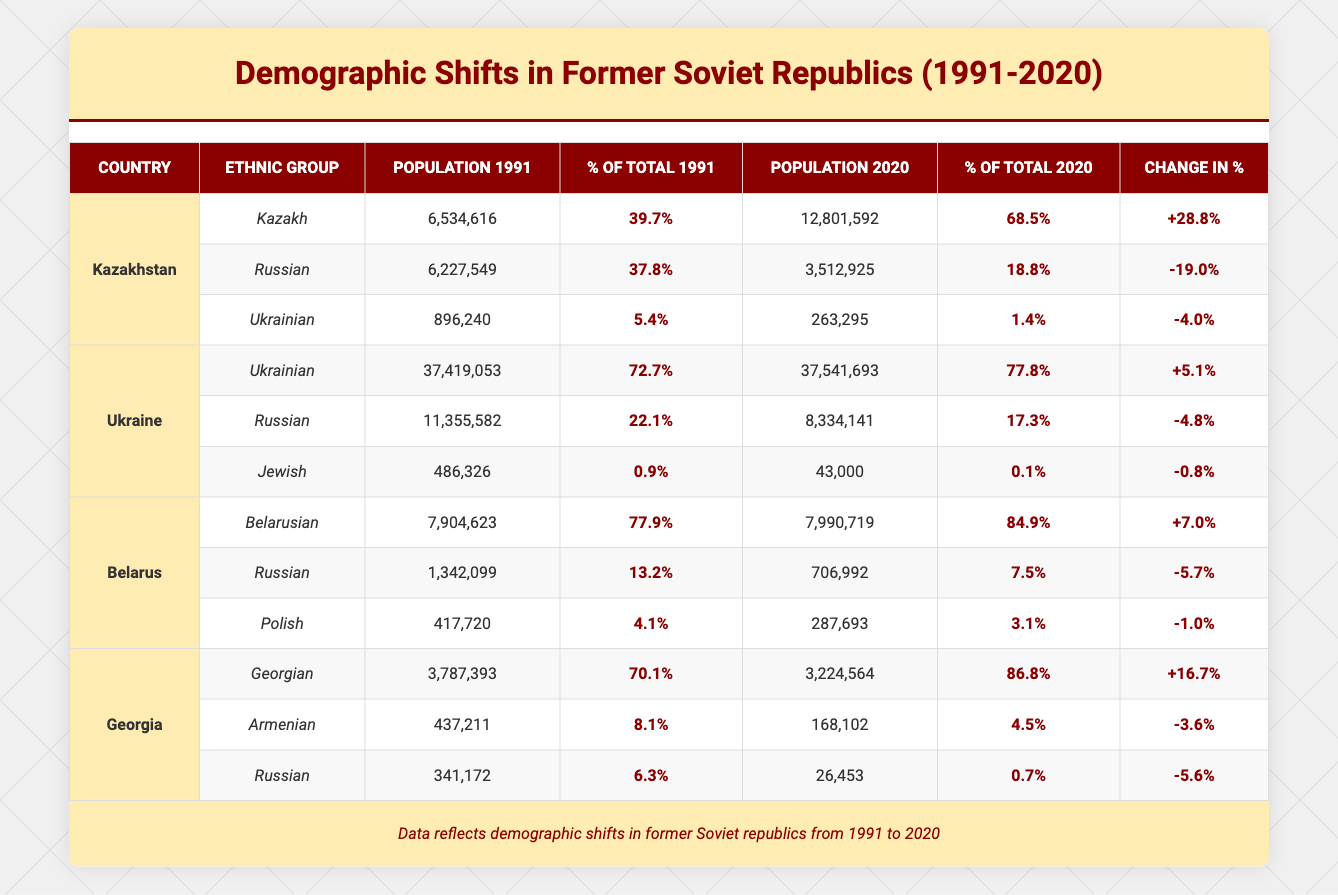What is the total population of Kazakhs in Kazakhstan in 2020? In the table, the population of Kazakhs in Kazakhstan in 2020 is listed as 12,801,592.
Answer: 12,801,592 What percentage of the total population did the Russian ethnic group represent in Belarus in 1991? The table indicates that in 1991, Russians represented 13.2% of the total population in Belarus.
Answer: 13.2% How many ethnic groups in Ukraine had a decrease in population from 1991 to 2020? The table shows that both the Russian and Jewish ethnic groups decreased in population in Ukraine. Thus, 2 ethnic groups had a population decrease.
Answer: 2 What was the percentage change for the Kazakh ethnic group in Kazakhstan from 1991 to 2020? The percentage for Kazakhs in 1991 was 39.7%, and in 2020 it rose to 68.5%. The change is calculated as 68.5 - 39.7 = 28.8%.
Answer: 28.8% Did the population of the Russian ethnic group in Georgia increase from 1991 to 2020? In the data, the Russian population in Georgia in 1991 was 341,172, which decreased to 26,453 in 2020, indicating a decline.
Answer: No What is the combined total population of Ukrainians and Russians in Ukraine in 2020? The table shows the Ukrainian population in 2020 as 37,541,693 and the Russian population as 8,334,141. Adding these gives 37,541,693 + 8,334,141 = 45,875,834.
Answer: 45,875,834 Which country has the highest percentage of its population as Belarusian in 2020? According to the table, Belarus has 84.9% of its population as Belarusian in 2020, which is the highest among the countries listed.
Answer: Belarus How did the ethnic composition of Georgia change in terms of the percentage of Georgians from 1991 to 2020? The percentage of Georgians in Georgia increased from 70.1% in 1991 to 86.8% in 2020, showing a significant rise of 16.7%.
Answer: Increased What is the difference in population between the Russian ethnic group in Belarus in 1991 and 2020? The population of Russians in Belarus was 1,342,099 in 1991 and decreased to 706,992 in 2020. The difference is 1,342,099 - 706,992 = 635,107.
Answer: 635,107 